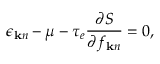<formula> <loc_0><loc_0><loc_500><loc_500>\epsilon _ { { k } n } - \mu - \tau _ { e } \frac { \partial S } { \partial f _ { { k } n } } = 0 ,</formula> 